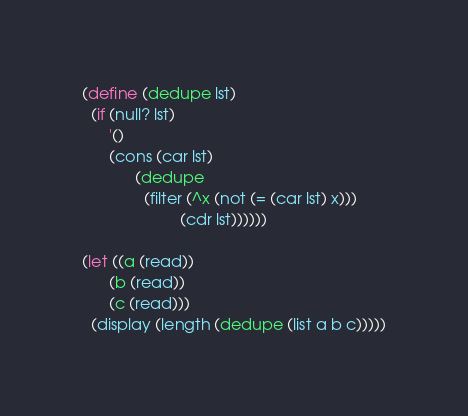Convert code to text. <code><loc_0><loc_0><loc_500><loc_500><_Scheme_>(define (dedupe lst)
  (if (null? lst)
      '()
      (cons (car lst)
            (dedupe
              (filter (^x (not (= (car lst) x))) 
                      (cdr lst))))))

(let ((a (read))
      (b (read))
      (c (read)))
  (display (length (dedupe (list a b c)))))

</code> 